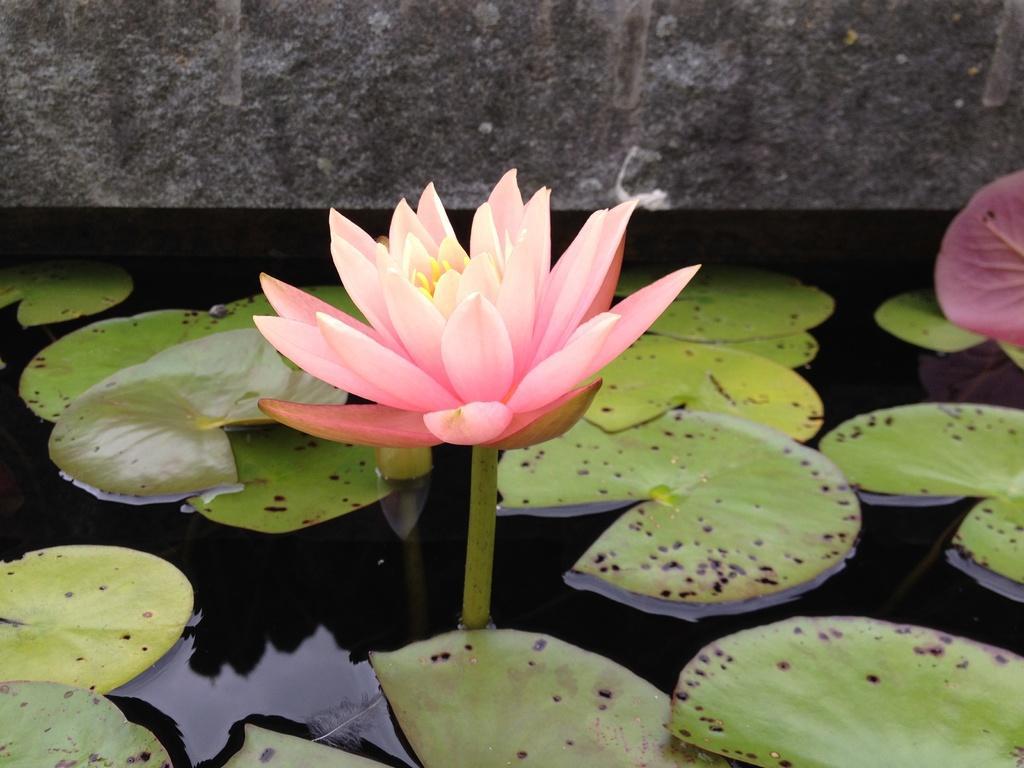Please provide a concise description of this image. In this image I can see water and on it I can see number of green colour leaves. I can also see a pink colour lotus in the center and on the right side of this image I can see a pink colour leaf. 